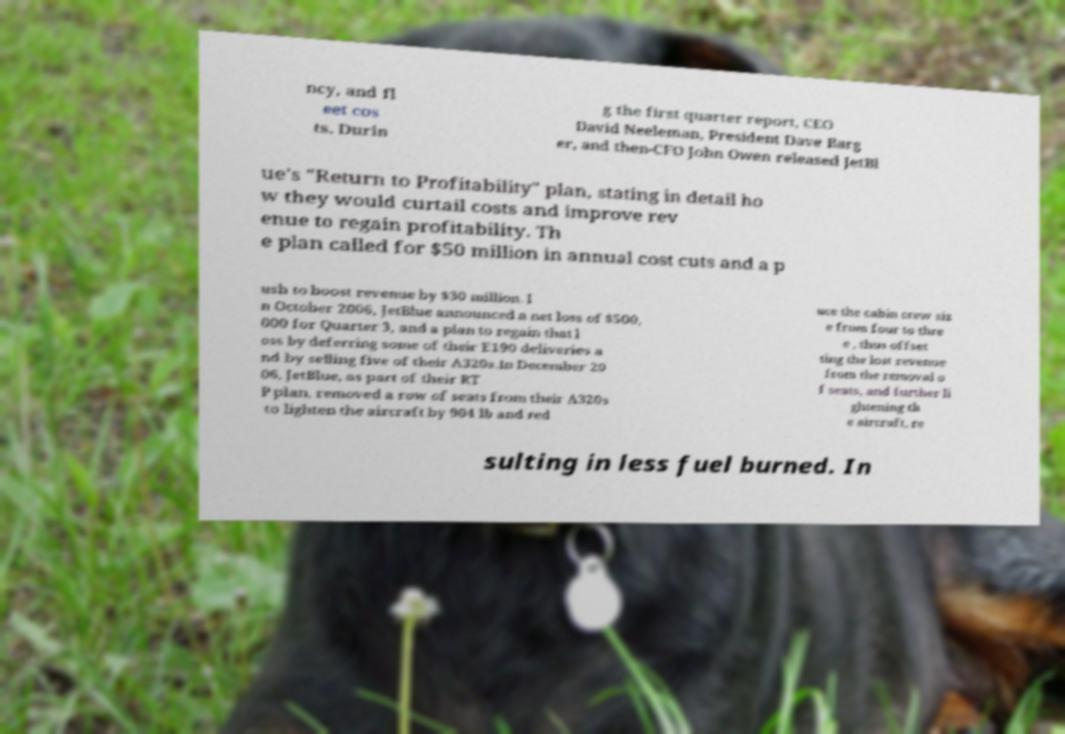Can you read and provide the text displayed in the image?This photo seems to have some interesting text. Can you extract and type it out for me? ncy, and fl eet cos ts. Durin g the first quarter report, CEO David Neeleman, President Dave Barg er, and then-CFO John Owen released JetBl ue's "Return to Profitability" plan, stating in detail ho w they would curtail costs and improve rev enue to regain profitability. Th e plan called for $50 million in annual cost cuts and a p ush to boost revenue by $30 million. I n October 2006, JetBlue announced a net loss of $500, 000 for Quarter 3, and a plan to regain that l oss by deferring some of their E190 deliveries a nd by selling five of their A320s.In December 20 06, JetBlue, as part of their RT P plan, removed a row of seats from their A320s to lighten the aircraft by 904 lb and red uce the cabin crew siz e from four to thre e , thus offset ting the lost revenue from the removal o f seats, and further li ghtening th e aircraft, re sulting in less fuel burned. In 